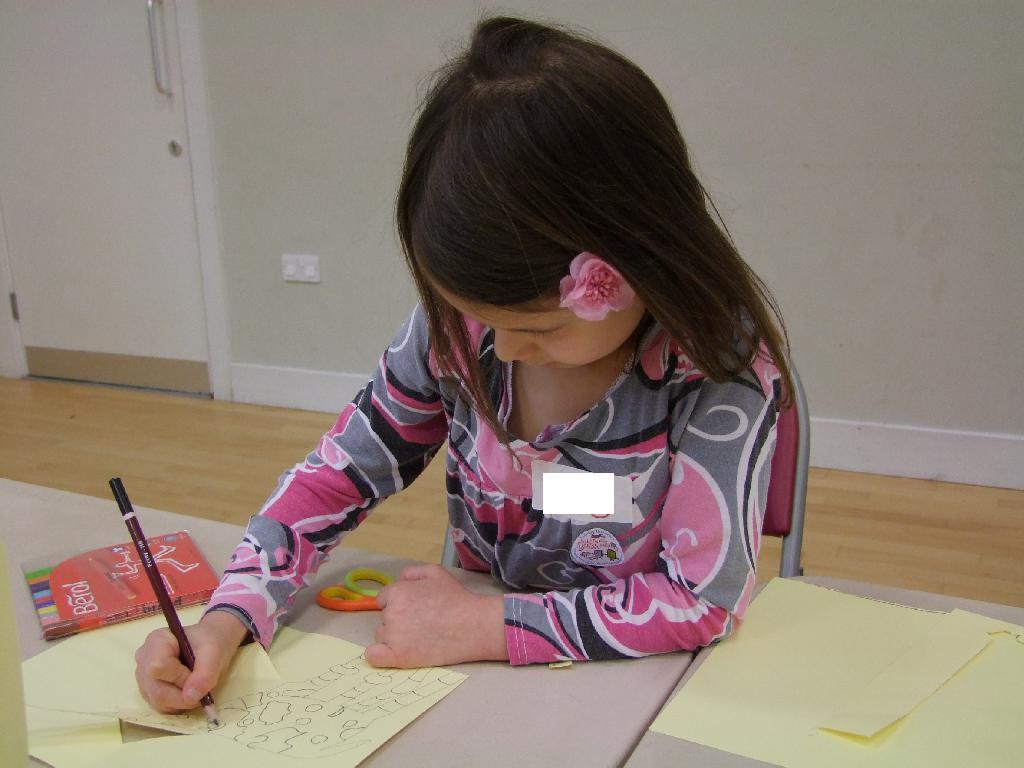Can you describe this image briefly? In this image there is a girl holding a pencil is writing on a paper, on the table there are some objects, the girl is sitting on a chair, behind the girl there is a wall with a closed door, on the wall there are electrical switches. 